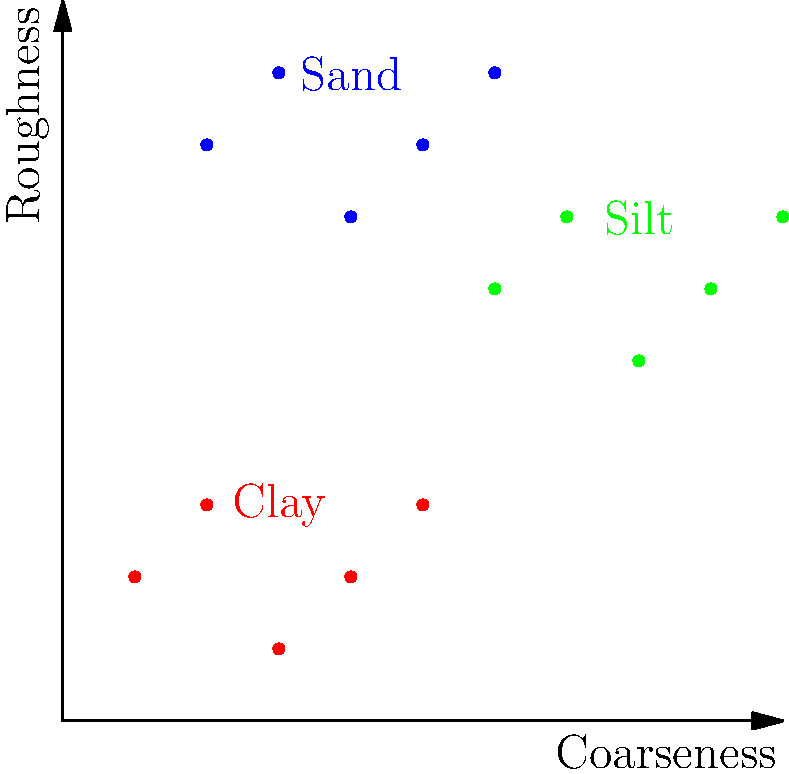As an engineer working on a machine learning challenge to detect pitch types from soil texture images, you've extracted features representing coarseness and roughness from the images. The scatter plot shows the distribution of these features for three soil types: clay (red), silt (green), and sand (blue). Which machine learning algorithm would be most suitable for classifying new soil samples based on these features, and why? To determine the most suitable machine learning algorithm for this classification task, let's analyze the problem step-by-step:

1. Data characteristics:
   - We have a 2D feature space (coarseness and roughness).
   - There are three distinct classes (clay, silt, and sand).
   - The classes appear to be linearly separable in the given feature space.

2. Problem type:
   - This is a multi-class classification problem.

3. Sample size:
   - The scatter plot shows a relatively small number of samples per class.

4. Decision boundary:
   - The classes seem to be separable by linear boundaries.

5. Computational efficiency:
   - As an engineer working on pitch detection, you likely need an algorithm that can make quick predictions during a cricket match.

6. Interpretability:
   - Understanding the decision-making process might be beneficial for fine-tuning the pitch detection system.

Based on these considerations, the most suitable algorithm would be Support Vector Machine (SVM) with a linear kernel. Here's why:

- SVMs are effective for linearly separable data, which appears to be the case here.
- They work well with small to medium-sized datasets.
- SVMs can handle multi-class classification problems efficiently.
- Linear SVMs are computationally efficient for making predictions, which is crucial for real-time pitch detection.
- The decision boundary of a linear SVM is interpretable, allowing you to understand how the features contribute to the classification.
- SVMs have good generalization properties, reducing the risk of overfitting on this small dataset.

While other algorithms like Logistic Regression or k-Nearest Neighbors could also be considered, SVM offers a good balance of performance, efficiency, and interpretability for this specific problem.
Answer: Support Vector Machine (SVM) with a linear kernel 